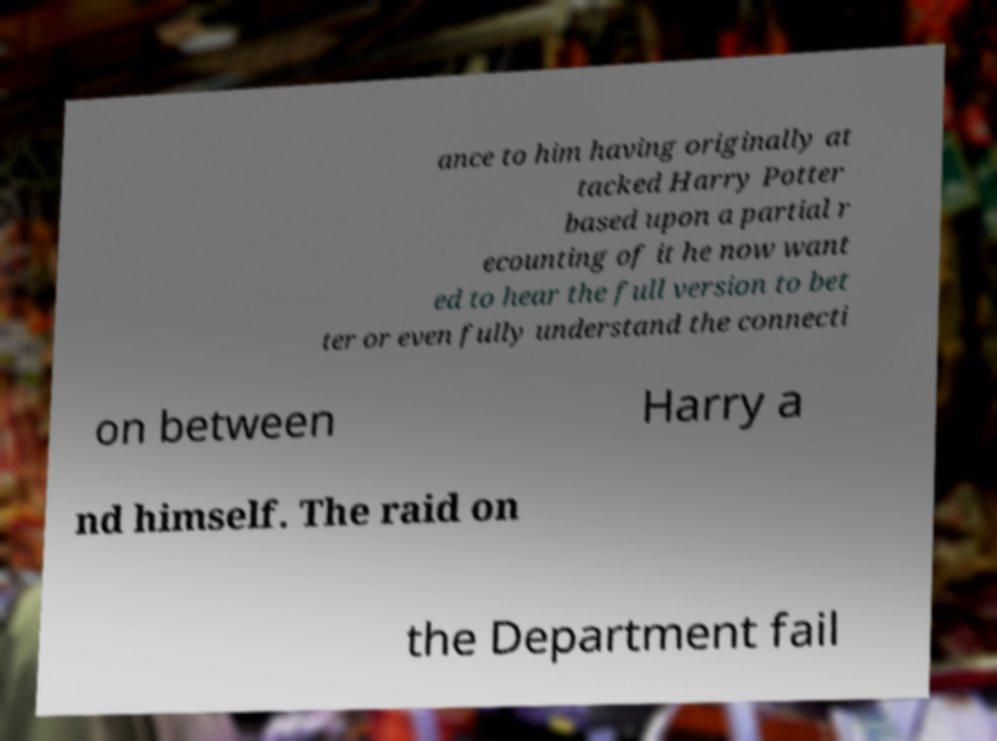I need the written content from this picture converted into text. Can you do that? ance to him having originally at tacked Harry Potter based upon a partial r ecounting of it he now want ed to hear the full version to bet ter or even fully understand the connecti on between Harry a nd himself. The raid on the Department fail 